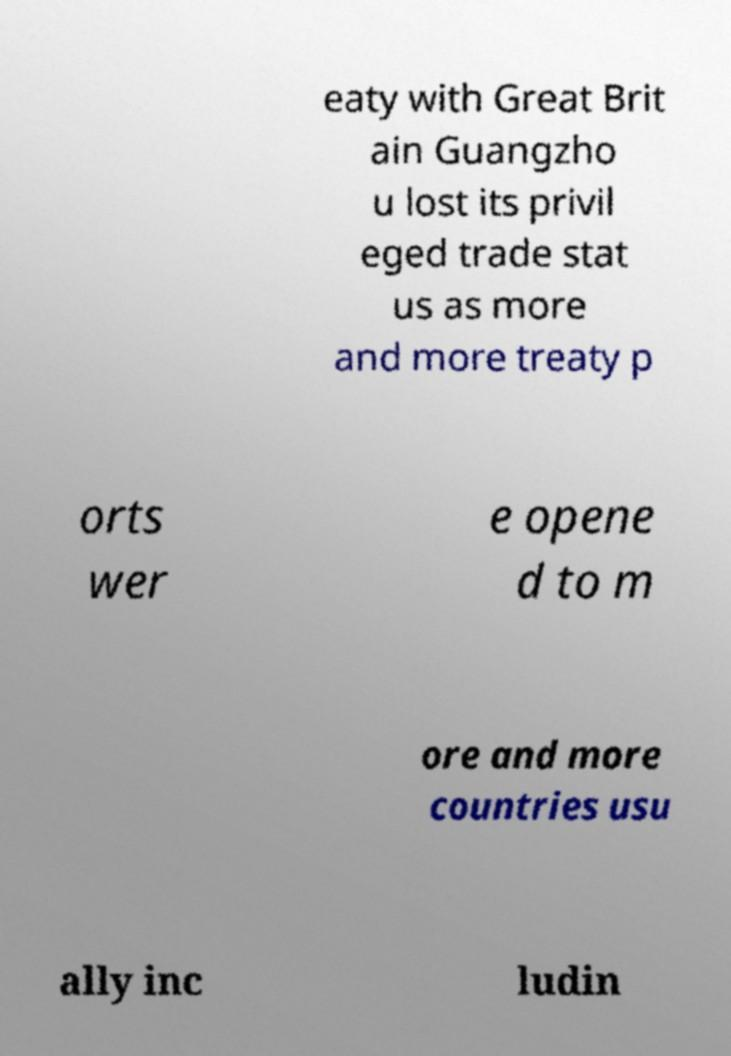What messages or text are displayed in this image? I need them in a readable, typed format. eaty with Great Brit ain Guangzho u lost its privil eged trade stat us as more and more treaty p orts wer e opene d to m ore and more countries usu ally inc ludin 